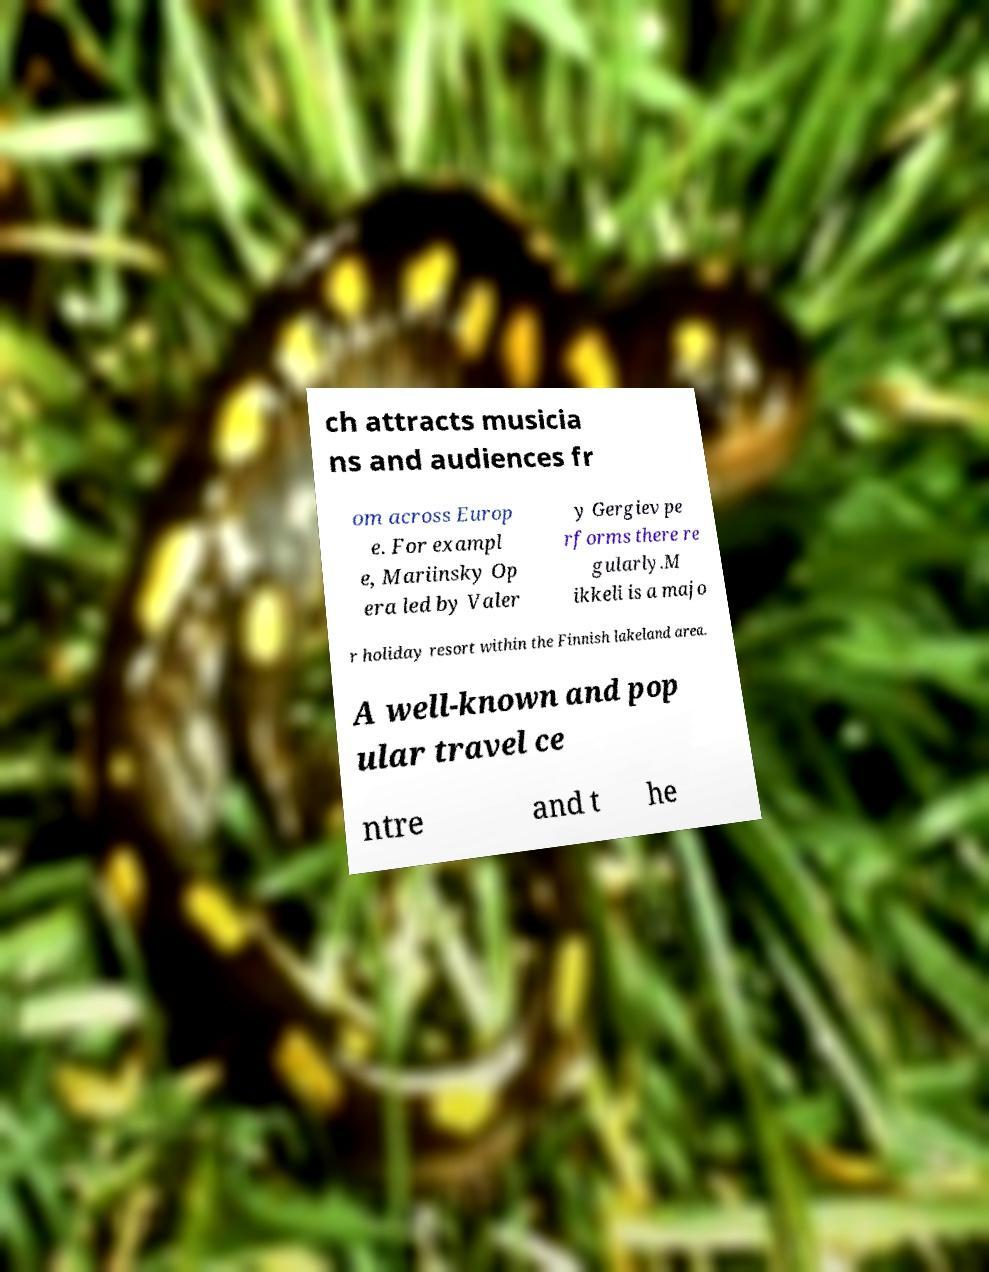Can you accurately transcribe the text from the provided image for me? ch attracts musicia ns and audiences fr om across Europ e. For exampl e, Mariinsky Op era led by Valer y Gergiev pe rforms there re gularly.M ikkeli is a majo r holiday resort within the Finnish lakeland area. A well-known and pop ular travel ce ntre and t he 